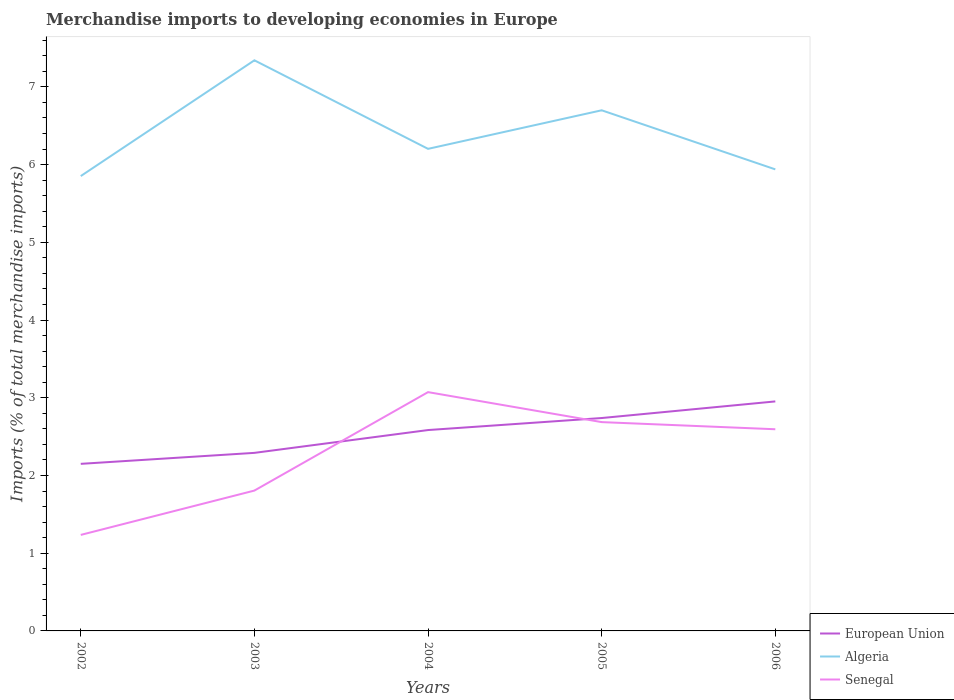Across all years, what is the maximum percentage total merchandise imports in Algeria?
Give a very brief answer. 5.85. What is the total percentage total merchandise imports in European Union in the graph?
Provide a short and direct response. -0.29. What is the difference between the highest and the second highest percentage total merchandise imports in Senegal?
Offer a very short reply. 1.84. How many lines are there?
Ensure brevity in your answer.  3. How many years are there in the graph?
Keep it short and to the point. 5. Are the values on the major ticks of Y-axis written in scientific E-notation?
Make the answer very short. No. Does the graph contain any zero values?
Keep it short and to the point. No. Where does the legend appear in the graph?
Your answer should be very brief. Bottom right. How many legend labels are there?
Give a very brief answer. 3. What is the title of the graph?
Offer a very short reply. Merchandise imports to developing economies in Europe. What is the label or title of the Y-axis?
Offer a very short reply. Imports (% of total merchandise imports). What is the Imports (% of total merchandise imports) of European Union in 2002?
Offer a very short reply. 2.15. What is the Imports (% of total merchandise imports) of Algeria in 2002?
Ensure brevity in your answer.  5.85. What is the Imports (% of total merchandise imports) of Senegal in 2002?
Ensure brevity in your answer.  1.24. What is the Imports (% of total merchandise imports) of European Union in 2003?
Make the answer very short. 2.29. What is the Imports (% of total merchandise imports) of Algeria in 2003?
Give a very brief answer. 7.34. What is the Imports (% of total merchandise imports) of Senegal in 2003?
Offer a terse response. 1.81. What is the Imports (% of total merchandise imports) of European Union in 2004?
Your answer should be very brief. 2.58. What is the Imports (% of total merchandise imports) in Algeria in 2004?
Offer a terse response. 6.2. What is the Imports (% of total merchandise imports) in Senegal in 2004?
Your response must be concise. 3.07. What is the Imports (% of total merchandise imports) in European Union in 2005?
Keep it short and to the point. 2.74. What is the Imports (% of total merchandise imports) of Algeria in 2005?
Keep it short and to the point. 6.7. What is the Imports (% of total merchandise imports) in Senegal in 2005?
Give a very brief answer. 2.69. What is the Imports (% of total merchandise imports) of European Union in 2006?
Your answer should be very brief. 2.95. What is the Imports (% of total merchandise imports) of Algeria in 2006?
Offer a terse response. 5.94. What is the Imports (% of total merchandise imports) in Senegal in 2006?
Provide a succinct answer. 2.59. Across all years, what is the maximum Imports (% of total merchandise imports) of European Union?
Your response must be concise. 2.95. Across all years, what is the maximum Imports (% of total merchandise imports) of Algeria?
Offer a terse response. 7.34. Across all years, what is the maximum Imports (% of total merchandise imports) in Senegal?
Offer a very short reply. 3.07. Across all years, what is the minimum Imports (% of total merchandise imports) in European Union?
Your answer should be compact. 2.15. Across all years, what is the minimum Imports (% of total merchandise imports) of Algeria?
Provide a short and direct response. 5.85. Across all years, what is the minimum Imports (% of total merchandise imports) in Senegal?
Your answer should be compact. 1.24. What is the total Imports (% of total merchandise imports) in European Union in the graph?
Make the answer very short. 12.72. What is the total Imports (% of total merchandise imports) in Algeria in the graph?
Keep it short and to the point. 32.03. What is the total Imports (% of total merchandise imports) in Senegal in the graph?
Provide a succinct answer. 11.4. What is the difference between the Imports (% of total merchandise imports) of European Union in 2002 and that in 2003?
Offer a terse response. -0.14. What is the difference between the Imports (% of total merchandise imports) in Algeria in 2002 and that in 2003?
Your response must be concise. -1.49. What is the difference between the Imports (% of total merchandise imports) in Senegal in 2002 and that in 2003?
Your answer should be compact. -0.57. What is the difference between the Imports (% of total merchandise imports) of European Union in 2002 and that in 2004?
Keep it short and to the point. -0.43. What is the difference between the Imports (% of total merchandise imports) in Algeria in 2002 and that in 2004?
Your answer should be very brief. -0.35. What is the difference between the Imports (% of total merchandise imports) of Senegal in 2002 and that in 2004?
Offer a very short reply. -1.84. What is the difference between the Imports (% of total merchandise imports) of European Union in 2002 and that in 2005?
Offer a very short reply. -0.59. What is the difference between the Imports (% of total merchandise imports) in Algeria in 2002 and that in 2005?
Your answer should be very brief. -0.85. What is the difference between the Imports (% of total merchandise imports) in Senegal in 2002 and that in 2005?
Provide a short and direct response. -1.45. What is the difference between the Imports (% of total merchandise imports) of European Union in 2002 and that in 2006?
Provide a succinct answer. -0.8. What is the difference between the Imports (% of total merchandise imports) in Algeria in 2002 and that in 2006?
Ensure brevity in your answer.  -0.09. What is the difference between the Imports (% of total merchandise imports) in Senegal in 2002 and that in 2006?
Provide a short and direct response. -1.36. What is the difference between the Imports (% of total merchandise imports) in European Union in 2003 and that in 2004?
Make the answer very short. -0.29. What is the difference between the Imports (% of total merchandise imports) of Algeria in 2003 and that in 2004?
Provide a short and direct response. 1.14. What is the difference between the Imports (% of total merchandise imports) of Senegal in 2003 and that in 2004?
Provide a succinct answer. -1.27. What is the difference between the Imports (% of total merchandise imports) of European Union in 2003 and that in 2005?
Your response must be concise. -0.45. What is the difference between the Imports (% of total merchandise imports) in Algeria in 2003 and that in 2005?
Keep it short and to the point. 0.64. What is the difference between the Imports (% of total merchandise imports) in Senegal in 2003 and that in 2005?
Your response must be concise. -0.88. What is the difference between the Imports (% of total merchandise imports) of European Union in 2003 and that in 2006?
Keep it short and to the point. -0.66. What is the difference between the Imports (% of total merchandise imports) of Algeria in 2003 and that in 2006?
Provide a short and direct response. 1.4. What is the difference between the Imports (% of total merchandise imports) in Senegal in 2003 and that in 2006?
Your answer should be very brief. -0.79. What is the difference between the Imports (% of total merchandise imports) of European Union in 2004 and that in 2005?
Your response must be concise. -0.15. What is the difference between the Imports (% of total merchandise imports) in Algeria in 2004 and that in 2005?
Provide a succinct answer. -0.5. What is the difference between the Imports (% of total merchandise imports) of Senegal in 2004 and that in 2005?
Offer a very short reply. 0.39. What is the difference between the Imports (% of total merchandise imports) in European Union in 2004 and that in 2006?
Your response must be concise. -0.37. What is the difference between the Imports (% of total merchandise imports) in Algeria in 2004 and that in 2006?
Your answer should be very brief. 0.26. What is the difference between the Imports (% of total merchandise imports) in Senegal in 2004 and that in 2006?
Provide a short and direct response. 0.48. What is the difference between the Imports (% of total merchandise imports) of European Union in 2005 and that in 2006?
Provide a short and direct response. -0.21. What is the difference between the Imports (% of total merchandise imports) of Algeria in 2005 and that in 2006?
Offer a terse response. 0.76. What is the difference between the Imports (% of total merchandise imports) of Senegal in 2005 and that in 2006?
Your response must be concise. 0.09. What is the difference between the Imports (% of total merchandise imports) in European Union in 2002 and the Imports (% of total merchandise imports) in Algeria in 2003?
Keep it short and to the point. -5.19. What is the difference between the Imports (% of total merchandise imports) of European Union in 2002 and the Imports (% of total merchandise imports) of Senegal in 2003?
Your answer should be compact. 0.34. What is the difference between the Imports (% of total merchandise imports) in Algeria in 2002 and the Imports (% of total merchandise imports) in Senegal in 2003?
Your answer should be compact. 4.05. What is the difference between the Imports (% of total merchandise imports) in European Union in 2002 and the Imports (% of total merchandise imports) in Algeria in 2004?
Your answer should be compact. -4.05. What is the difference between the Imports (% of total merchandise imports) of European Union in 2002 and the Imports (% of total merchandise imports) of Senegal in 2004?
Offer a very short reply. -0.92. What is the difference between the Imports (% of total merchandise imports) in Algeria in 2002 and the Imports (% of total merchandise imports) in Senegal in 2004?
Provide a short and direct response. 2.78. What is the difference between the Imports (% of total merchandise imports) in European Union in 2002 and the Imports (% of total merchandise imports) in Algeria in 2005?
Your response must be concise. -4.55. What is the difference between the Imports (% of total merchandise imports) in European Union in 2002 and the Imports (% of total merchandise imports) in Senegal in 2005?
Your answer should be very brief. -0.54. What is the difference between the Imports (% of total merchandise imports) in Algeria in 2002 and the Imports (% of total merchandise imports) in Senegal in 2005?
Keep it short and to the point. 3.17. What is the difference between the Imports (% of total merchandise imports) in European Union in 2002 and the Imports (% of total merchandise imports) in Algeria in 2006?
Make the answer very short. -3.79. What is the difference between the Imports (% of total merchandise imports) of European Union in 2002 and the Imports (% of total merchandise imports) of Senegal in 2006?
Provide a short and direct response. -0.45. What is the difference between the Imports (% of total merchandise imports) of Algeria in 2002 and the Imports (% of total merchandise imports) of Senegal in 2006?
Make the answer very short. 3.26. What is the difference between the Imports (% of total merchandise imports) of European Union in 2003 and the Imports (% of total merchandise imports) of Algeria in 2004?
Make the answer very short. -3.91. What is the difference between the Imports (% of total merchandise imports) in European Union in 2003 and the Imports (% of total merchandise imports) in Senegal in 2004?
Make the answer very short. -0.78. What is the difference between the Imports (% of total merchandise imports) of Algeria in 2003 and the Imports (% of total merchandise imports) of Senegal in 2004?
Keep it short and to the point. 4.27. What is the difference between the Imports (% of total merchandise imports) of European Union in 2003 and the Imports (% of total merchandise imports) of Algeria in 2005?
Your response must be concise. -4.41. What is the difference between the Imports (% of total merchandise imports) of European Union in 2003 and the Imports (% of total merchandise imports) of Senegal in 2005?
Keep it short and to the point. -0.4. What is the difference between the Imports (% of total merchandise imports) of Algeria in 2003 and the Imports (% of total merchandise imports) of Senegal in 2005?
Your answer should be compact. 4.66. What is the difference between the Imports (% of total merchandise imports) of European Union in 2003 and the Imports (% of total merchandise imports) of Algeria in 2006?
Make the answer very short. -3.65. What is the difference between the Imports (% of total merchandise imports) of European Union in 2003 and the Imports (% of total merchandise imports) of Senegal in 2006?
Offer a terse response. -0.3. What is the difference between the Imports (% of total merchandise imports) in Algeria in 2003 and the Imports (% of total merchandise imports) in Senegal in 2006?
Provide a succinct answer. 4.75. What is the difference between the Imports (% of total merchandise imports) in European Union in 2004 and the Imports (% of total merchandise imports) in Algeria in 2005?
Your response must be concise. -4.11. What is the difference between the Imports (% of total merchandise imports) in European Union in 2004 and the Imports (% of total merchandise imports) in Senegal in 2005?
Offer a terse response. -0.1. What is the difference between the Imports (% of total merchandise imports) of Algeria in 2004 and the Imports (% of total merchandise imports) of Senegal in 2005?
Provide a succinct answer. 3.52. What is the difference between the Imports (% of total merchandise imports) of European Union in 2004 and the Imports (% of total merchandise imports) of Algeria in 2006?
Your response must be concise. -3.35. What is the difference between the Imports (% of total merchandise imports) in European Union in 2004 and the Imports (% of total merchandise imports) in Senegal in 2006?
Keep it short and to the point. -0.01. What is the difference between the Imports (% of total merchandise imports) of Algeria in 2004 and the Imports (% of total merchandise imports) of Senegal in 2006?
Give a very brief answer. 3.61. What is the difference between the Imports (% of total merchandise imports) of European Union in 2005 and the Imports (% of total merchandise imports) of Algeria in 2006?
Give a very brief answer. -3.2. What is the difference between the Imports (% of total merchandise imports) in European Union in 2005 and the Imports (% of total merchandise imports) in Senegal in 2006?
Offer a very short reply. 0.14. What is the difference between the Imports (% of total merchandise imports) of Algeria in 2005 and the Imports (% of total merchandise imports) of Senegal in 2006?
Offer a terse response. 4.1. What is the average Imports (% of total merchandise imports) in European Union per year?
Your answer should be compact. 2.54. What is the average Imports (% of total merchandise imports) of Algeria per year?
Offer a terse response. 6.41. What is the average Imports (% of total merchandise imports) of Senegal per year?
Ensure brevity in your answer.  2.28. In the year 2002, what is the difference between the Imports (% of total merchandise imports) in European Union and Imports (% of total merchandise imports) in Algeria?
Give a very brief answer. -3.7. In the year 2002, what is the difference between the Imports (% of total merchandise imports) in European Union and Imports (% of total merchandise imports) in Senegal?
Offer a terse response. 0.91. In the year 2002, what is the difference between the Imports (% of total merchandise imports) in Algeria and Imports (% of total merchandise imports) in Senegal?
Ensure brevity in your answer.  4.62. In the year 2003, what is the difference between the Imports (% of total merchandise imports) in European Union and Imports (% of total merchandise imports) in Algeria?
Ensure brevity in your answer.  -5.05. In the year 2003, what is the difference between the Imports (% of total merchandise imports) of European Union and Imports (% of total merchandise imports) of Senegal?
Ensure brevity in your answer.  0.49. In the year 2003, what is the difference between the Imports (% of total merchandise imports) in Algeria and Imports (% of total merchandise imports) in Senegal?
Give a very brief answer. 5.54. In the year 2004, what is the difference between the Imports (% of total merchandise imports) of European Union and Imports (% of total merchandise imports) of Algeria?
Offer a very short reply. -3.62. In the year 2004, what is the difference between the Imports (% of total merchandise imports) in European Union and Imports (% of total merchandise imports) in Senegal?
Your response must be concise. -0.49. In the year 2004, what is the difference between the Imports (% of total merchandise imports) of Algeria and Imports (% of total merchandise imports) of Senegal?
Ensure brevity in your answer.  3.13. In the year 2005, what is the difference between the Imports (% of total merchandise imports) in European Union and Imports (% of total merchandise imports) in Algeria?
Your answer should be compact. -3.96. In the year 2005, what is the difference between the Imports (% of total merchandise imports) in European Union and Imports (% of total merchandise imports) in Senegal?
Your answer should be very brief. 0.05. In the year 2005, what is the difference between the Imports (% of total merchandise imports) in Algeria and Imports (% of total merchandise imports) in Senegal?
Your answer should be compact. 4.01. In the year 2006, what is the difference between the Imports (% of total merchandise imports) in European Union and Imports (% of total merchandise imports) in Algeria?
Keep it short and to the point. -2.99. In the year 2006, what is the difference between the Imports (% of total merchandise imports) in European Union and Imports (% of total merchandise imports) in Senegal?
Make the answer very short. 0.36. In the year 2006, what is the difference between the Imports (% of total merchandise imports) in Algeria and Imports (% of total merchandise imports) in Senegal?
Make the answer very short. 3.34. What is the ratio of the Imports (% of total merchandise imports) of European Union in 2002 to that in 2003?
Provide a succinct answer. 0.94. What is the ratio of the Imports (% of total merchandise imports) of Algeria in 2002 to that in 2003?
Offer a very short reply. 0.8. What is the ratio of the Imports (% of total merchandise imports) in Senegal in 2002 to that in 2003?
Your answer should be compact. 0.68. What is the ratio of the Imports (% of total merchandise imports) in European Union in 2002 to that in 2004?
Your answer should be very brief. 0.83. What is the ratio of the Imports (% of total merchandise imports) in Algeria in 2002 to that in 2004?
Give a very brief answer. 0.94. What is the ratio of the Imports (% of total merchandise imports) of Senegal in 2002 to that in 2004?
Offer a very short reply. 0.4. What is the ratio of the Imports (% of total merchandise imports) in European Union in 2002 to that in 2005?
Give a very brief answer. 0.78. What is the ratio of the Imports (% of total merchandise imports) in Algeria in 2002 to that in 2005?
Your answer should be compact. 0.87. What is the ratio of the Imports (% of total merchandise imports) of Senegal in 2002 to that in 2005?
Offer a terse response. 0.46. What is the ratio of the Imports (% of total merchandise imports) in European Union in 2002 to that in 2006?
Keep it short and to the point. 0.73. What is the ratio of the Imports (% of total merchandise imports) of Algeria in 2002 to that in 2006?
Your answer should be compact. 0.99. What is the ratio of the Imports (% of total merchandise imports) in Senegal in 2002 to that in 2006?
Provide a short and direct response. 0.48. What is the ratio of the Imports (% of total merchandise imports) of European Union in 2003 to that in 2004?
Make the answer very short. 0.89. What is the ratio of the Imports (% of total merchandise imports) of Algeria in 2003 to that in 2004?
Provide a succinct answer. 1.18. What is the ratio of the Imports (% of total merchandise imports) in Senegal in 2003 to that in 2004?
Your response must be concise. 0.59. What is the ratio of the Imports (% of total merchandise imports) of European Union in 2003 to that in 2005?
Your answer should be very brief. 0.84. What is the ratio of the Imports (% of total merchandise imports) in Algeria in 2003 to that in 2005?
Your answer should be very brief. 1.1. What is the ratio of the Imports (% of total merchandise imports) of Senegal in 2003 to that in 2005?
Give a very brief answer. 0.67. What is the ratio of the Imports (% of total merchandise imports) in European Union in 2003 to that in 2006?
Keep it short and to the point. 0.78. What is the ratio of the Imports (% of total merchandise imports) in Algeria in 2003 to that in 2006?
Make the answer very short. 1.24. What is the ratio of the Imports (% of total merchandise imports) in Senegal in 2003 to that in 2006?
Your answer should be compact. 0.7. What is the ratio of the Imports (% of total merchandise imports) in European Union in 2004 to that in 2005?
Make the answer very short. 0.94. What is the ratio of the Imports (% of total merchandise imports) of Algeria in 2004 to that in 2005?
Your answer should be very brief. 0.93. What is the ratio of the Imports (% of total merchandise imports) in Senegal in 2004 to that in 2005?
Offer a terse response. 1.14. What is the ratio of the Imports (% of total merchandise imports) of European Union in 2004 to that in 2006?
Your response must be concise. 0.88. What is the ratio of the Imports (% of total merchandise imports) in Algeria in 2004 to that in 2006?
Your answer should be compact. 1.04. What is the ratio of the Imports (% of total merchandise imports) of Senegal in 2004 to that in 2006?
Keep it short and to the point. 1.18. What is the ratio of the Imports (% of total merchandise imports) of European Union in 2005 to that in 2006?
Ensure brevity in your answer.  0.93. What is the ratio of the Imports (% of total merchandise imports) in Algeria in 2005 to that in 2006?
Your response must be concise. 1.13. What is the ratio of the Imports (% of total merchandise imports) of Senegal in 2005 to that in 2006?
Your answer should be very brief. 1.04. What is the difference between the highest and the second highest Imports (% of total merchandise imports) in European Union?
Give a very brief answer. 0.21. What is the difference between the highest and the second highest Imports (% of total merchandise imports) in Algeria?
Offer a terse response. 0.64. What is the difference between the highest and the second highest Imports (% of total merchandise imports) in Senegal?
Make the answer very short. 0.39. What is the difference between the highest and the lowest Imports (% of total merchandise imports) in European Union?
Ensure brevity in your answer.  0.8. What is the difference between the highest and the lowest Imports (% of total merchandise imports) in Algeria?
Provide a short and direct response. 1.49. What is the difference between the highest and the lowest Imports (% of total merchandise imports) of Senegal?
Provide a short and direct response. 1.84. 